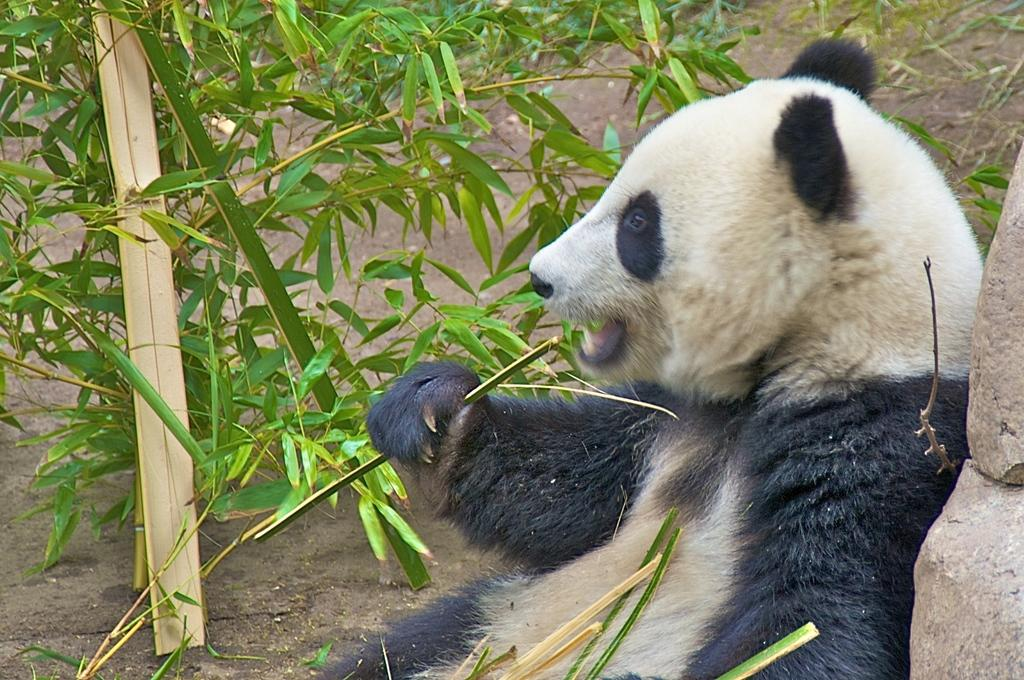What is the main subject in the center of the image? There is an animal in the center of the image. What can be seen in the background of the image? There are plants and mud in the background of the image. What type of natural feature is present on the right side of the image? There are rocks on the right side of the image. Where is the vase located in the image? There is no vase present in the image. How much sugar can be seen in the image? There is no sugar present in the image. 